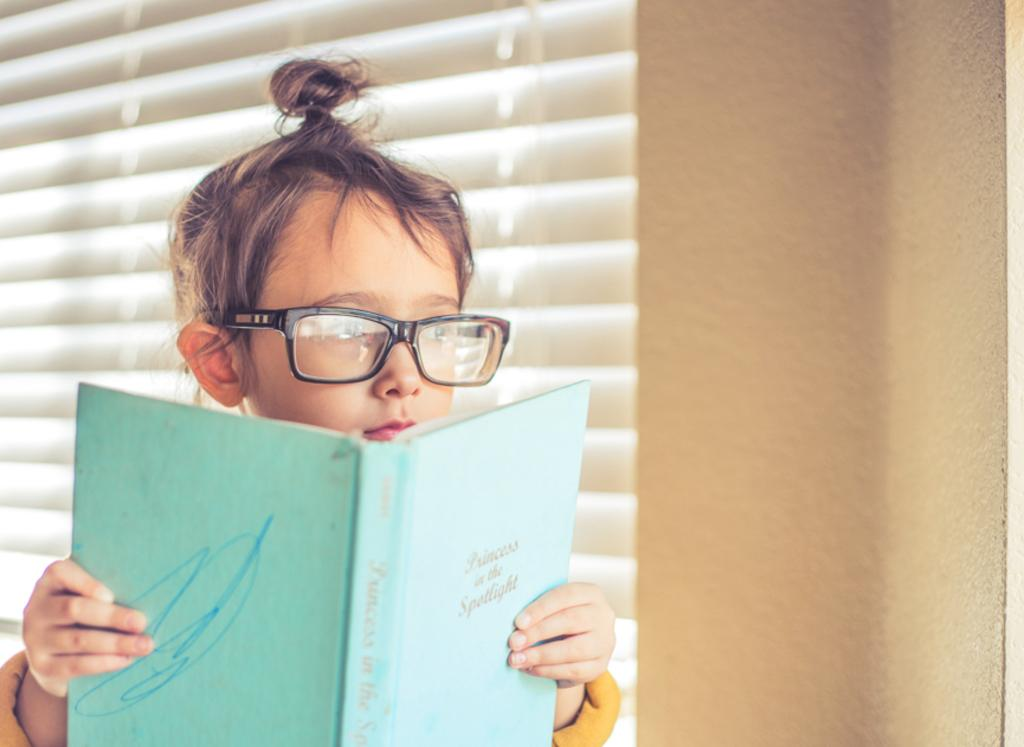What is on the left side of the image? There is a kid on the left side of the image. What is the kid holding in the image? The kid is holding a book. Can you describe the kid's appearance? The kid is wearing spectacles. What can be seen in the background of the image? There are window blinds in the background of the image. What type of ink is being used to write on the park bench in the image? There is no park bench or ink present in the image. 